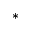<formula> <loc_0><loc_0><loc_500><loc_500>^ { * }</formula> 